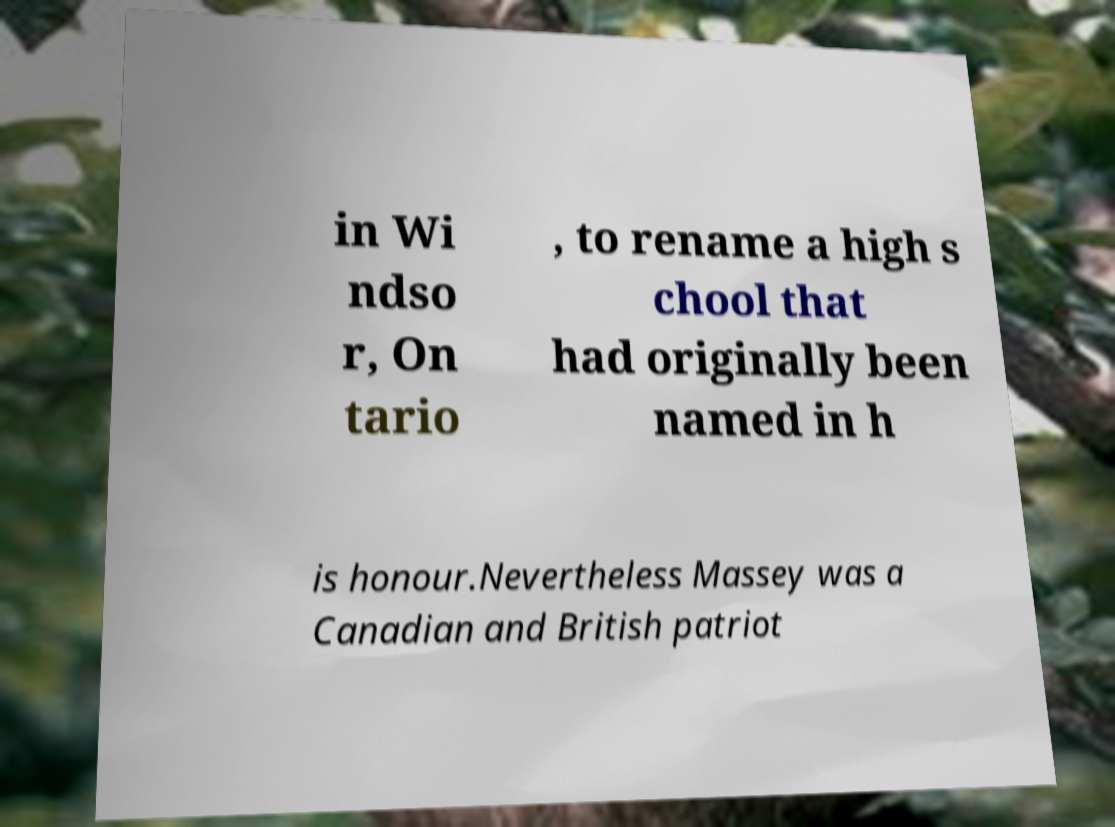What messages or text are displayed in this image? I need them in a readable, typed format. in Wi ndso r, On tario , to rename a high s chool that had originally been named in h is honour.Nevertheless Massey was a Canadian and British patriot 